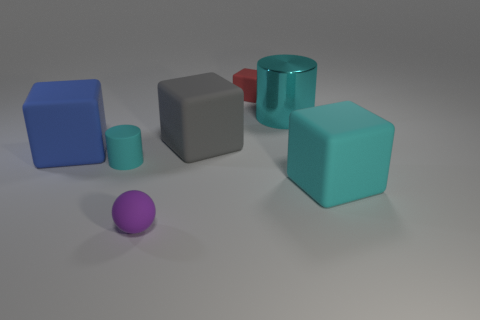There is a tiny cylinder that is the same color as the metallic object; what is it made of?
Your answer should be very brief. Rubber. Is the number of small purple things less than the number of big green objects?
Provide a succinct answer. No. Does the large block that is to the right of the large metal cylinder have the same color as the big cylinder?
Keep it short and to the point. Yes. What is the color of the small block that is the same material as the big blue object?
Make the answer very short. Red. Do the shiny thing and the purple rubber sphere have the same size?
Offer a terse response. No. What is the gray cube made of?
Provide a succinct answer. Rubber. There is a cylinder that is the same size as the matte ball; what is its material?
Your answer should be compact. Rubber. Is there a gray rubber cylinder of the same size as the cyan rubber cube?
Your answer should be compact. No. Are there an equal number of gray things that are left of the tiny cyan thing and small things that are behind the small sphere?
Offer a very short reply. No. Are there more tiny cubes than cyan cylinders?
Offer a terse response. No. 